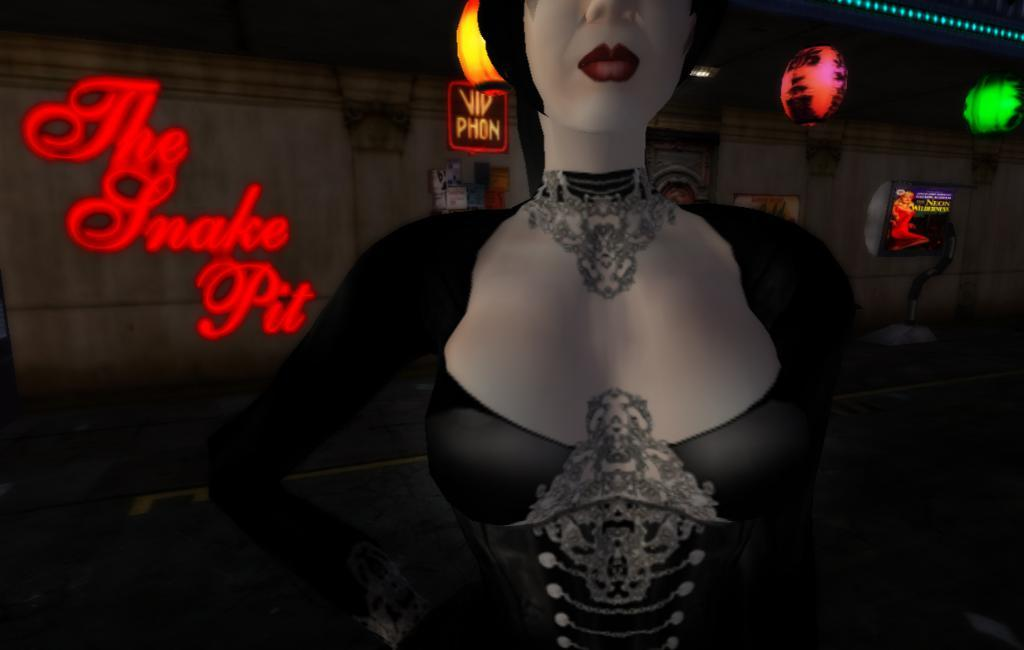What is the main subject of the picture? The main subject of the picture is an animation image of a girl. What is the girl wearing in the image? The girl is wearing jewellery in the image. What can be seen in the background of the image? There is a wall in the background of the image. What type of lighting is present on the wall? LED lights are present on the wall. What is hanging at the top of the image? There are hangings at the top of the image. What type of range can be seen in the image? There is no range present in the image; it features an animation image of a girl. What type of stitch is used to create the girl's clothing in the image? The image is an animation, so it does not have a physical stitch used to create the girl's clothing. 